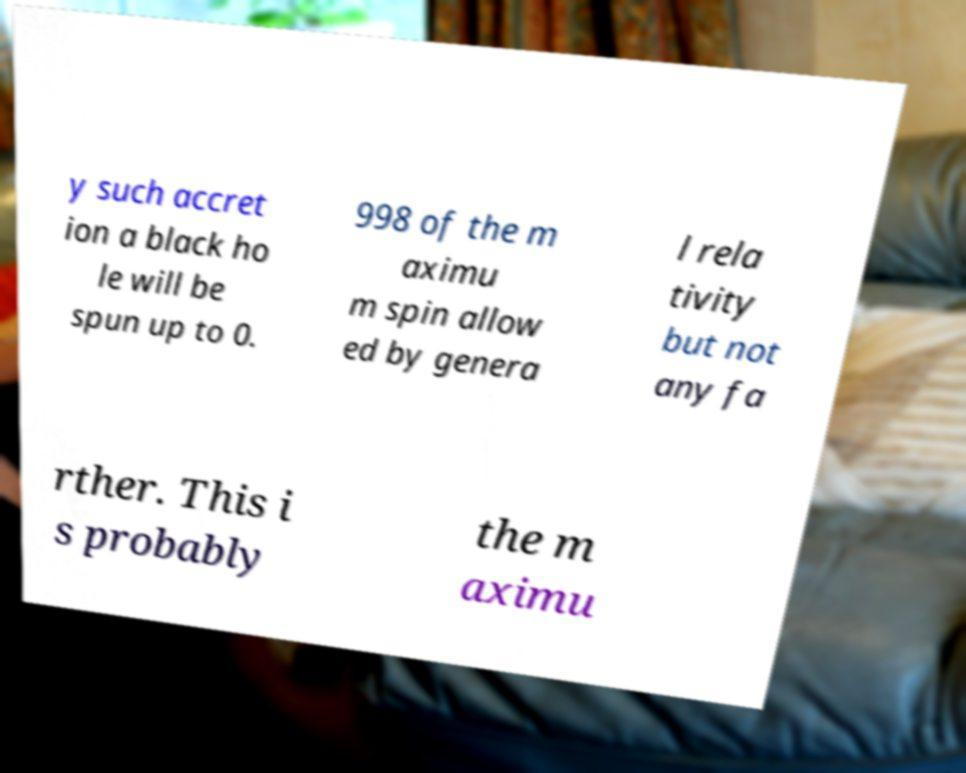For documentation purposes, I need the text within this image transcribed. Could you provide that? y such accret ion a black ho le will be spun up to 0. 998 of the m aximu m spin allow ed by genera l rela tivity but not any fa rther. This i s probably the m aximu 